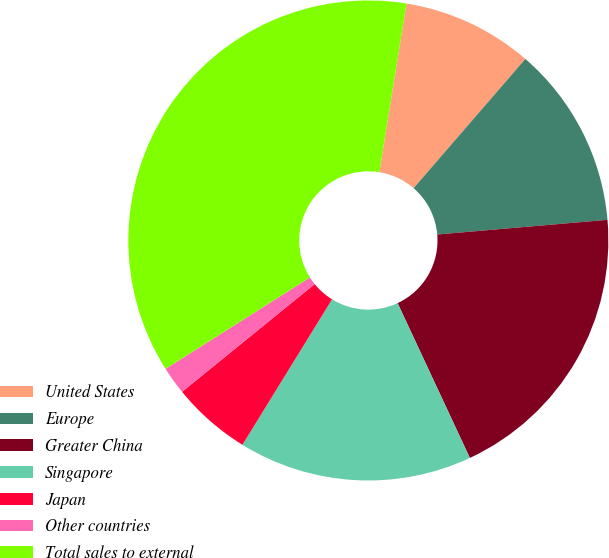<chart> <loc_0><loc_0><loc_500><loc_500><pie_chart><fcel>United States<fcel>Europe<fcel>Greater China<fcel>Singapore<fcel>Japan<fcel>Other countries<fcel>Total sales to external<nl><fcel>8.81%<fcel>12.28%<fcel>19.42%<fcel>15.74%<fcel>5.35%<fcel>1.88%<fcel>36.52%<nl></chart> 